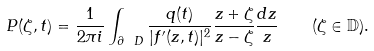Convert formula to latex. <formula><loc_0><loc_0><loc_500><loc_500>P ( \zeta , t ) = \frac { 1 } { 2 \pi i } \int _ { \partial \ D } \frac { q ( t ) } { | f ^ { \prime } ( z , t ) | ^ { 2 } } \frac { z + \zeta } { z - \zeta } \frac { d z } { z } \quad ( \zeta \in \mathbb { D } ) .</formula> 